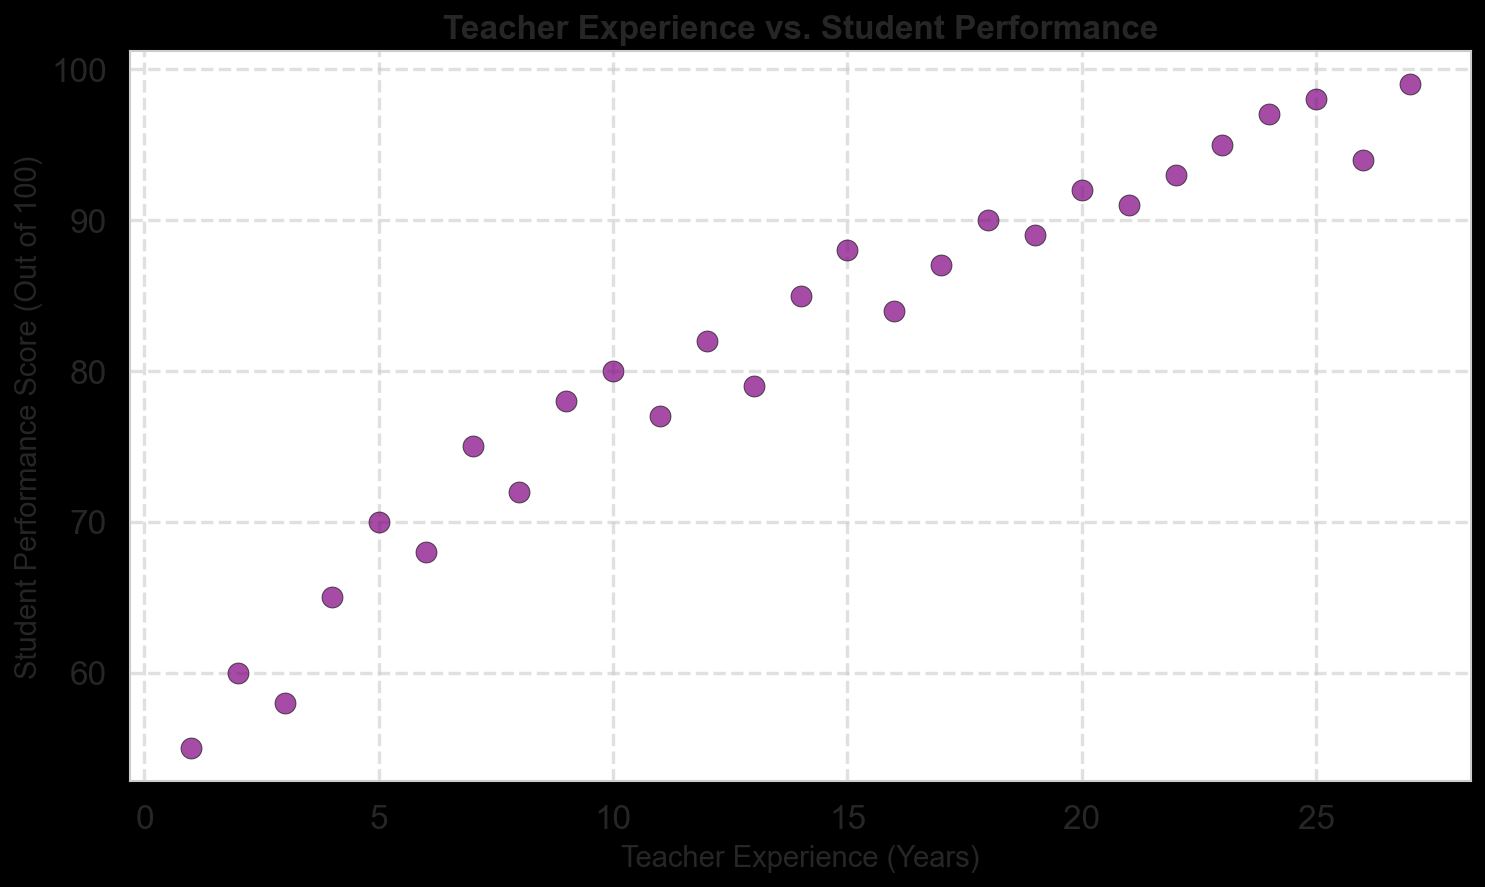Which data point represents the highest student performance score? To solve this, identify the point with the highest y-coordinate. The highest score is 99 at 27 years of experience.
Answer: 99 at 27 years What's the average student performance score of teachers with 5 to 10 years of experience? Calculate the scores for the range 5 to 10 years, sum them and divide by the number of data points. The scores are 70, 68, 75, 72, 78, and 80, summing up to 443. Average = 443/6 = 73.83.
Answer: 73.83 Which data point has the lowest student performance score? Find the point with the lowest y-coordinate. The lowest score is 55 at 1 year of experience.
Answer: 55 at 1 year How does the student performance trend with increasing teacher experience? Observe the overall pattern in the scatter plot. Scores generally increase with more experience.
Answer: Increasing What is the difference in student performance scores between teachers with 15 years and 25 years of experience? Compare the scores at 15 and 25 years. Score at 15 years is 88 and at 25 years is 98. Difference = 98 - 88 = 10.
Answer: 10 At how many years of teaching experience do we first see a student performance score of 90 or above? Locate the first occurrence of y ≥ 90 on the scatter plot, which happens at 18 years of experience.
Answer: 18 years How many teachers have student performance scores that exceed 85? Count the points above y = 85. Teachers with scores above 85 are 15, 17, 18, 19, 20, 21, 22, 23, 24, 25, 27 years. There are 11 such teachers.
Answer: 11 Is there any teacher with exactly 10 years of experience? What is their student performance score? Find if there is a point at 10 years on the x-axis. There is a point, and the score at 10 years is 80.
Answer: Yes, 80 What is the median student performance score for all teachers? Sort the scores and find the middle value. There are 27 points, so the median is the 14th value. Sorted scores=55, 58, 60, 65, 68, 70, 72, 75, 77, 78, 79, 80, 82, 84, 85, 87, 88, 89, 90, 91, 92, 93, 94, 95, 97, 98, 99. Median is 84.
Answer: 84 